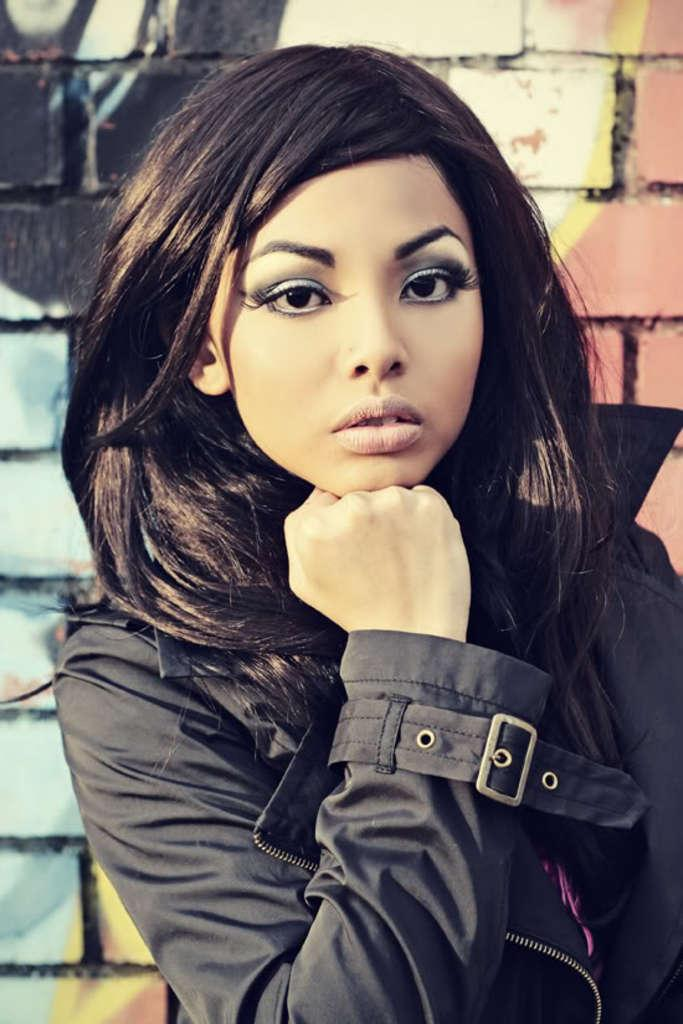Who is the main subject in the image? There is a girl standing in the center of the image. What is the girl wearing? The girl is wearing a jacket. What can be seen in the background of the image? There is a wall in the background of the image. How many women are using a comb in the image? There are no women using a comb in the image, as it only features a girl standing in the center. 